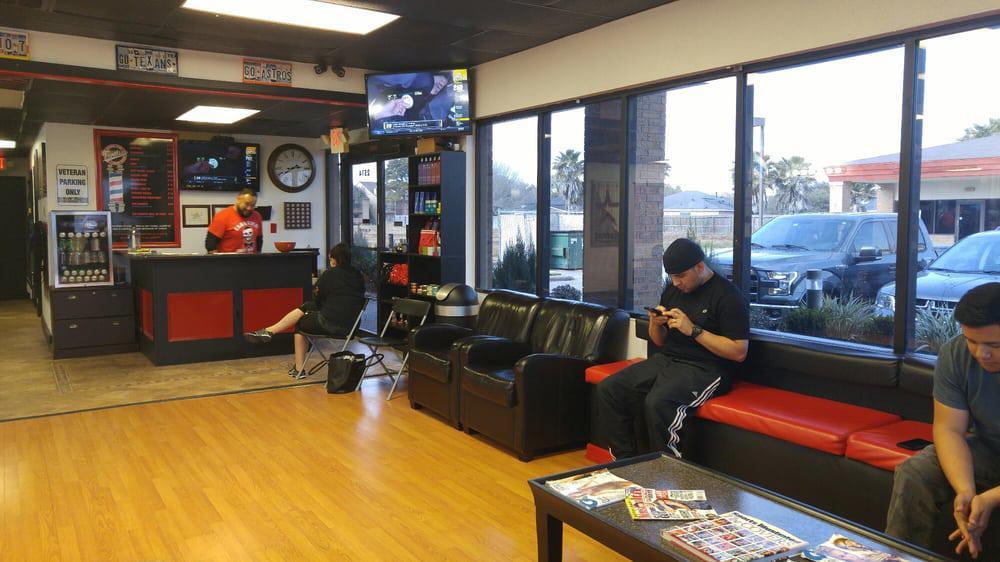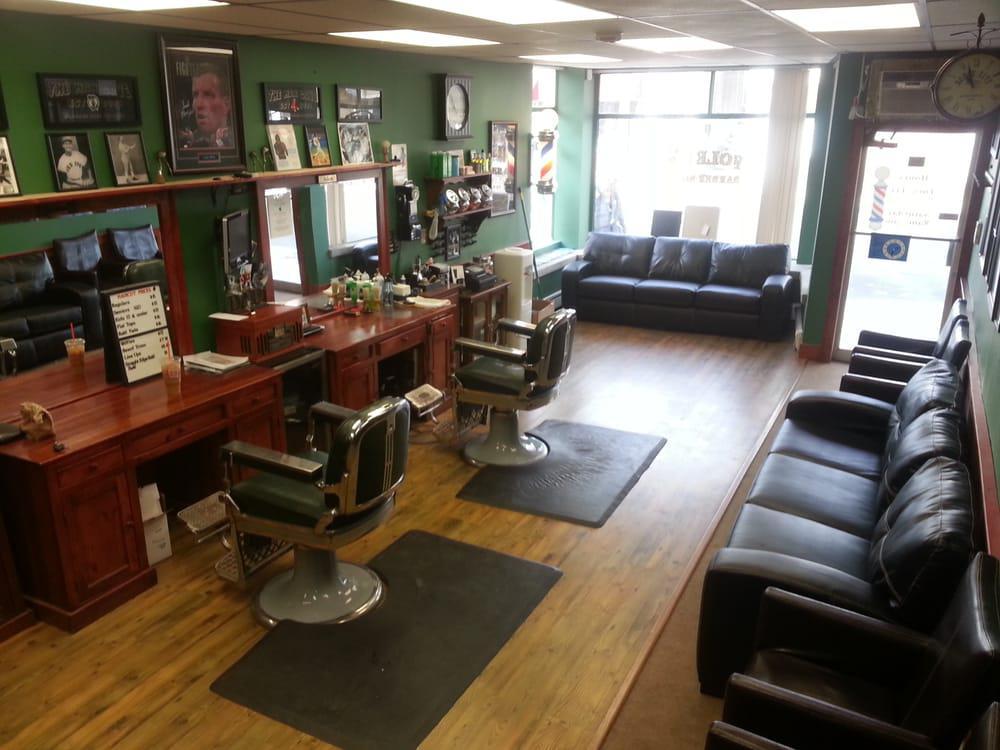The first image is the image on the left, the second image is the image on the right. For the images shown, is this caption "In one of the image there is at least one man sitting down on a couch." true? Answer yes or no. Yes. 